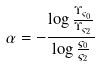Convert formula to latex. <formula><loc_0><loc_0><loc_500><loc_500>\alpha = - \frac { \log \frac { \Upsilon _ { \varsigma _ { 0 } } } { \Upsilon _ { \varsigma _ { 2 } } } } { \log \frac { \varsigma _ { 0 } } { \varsigma _ { 2 } } }</formula> 